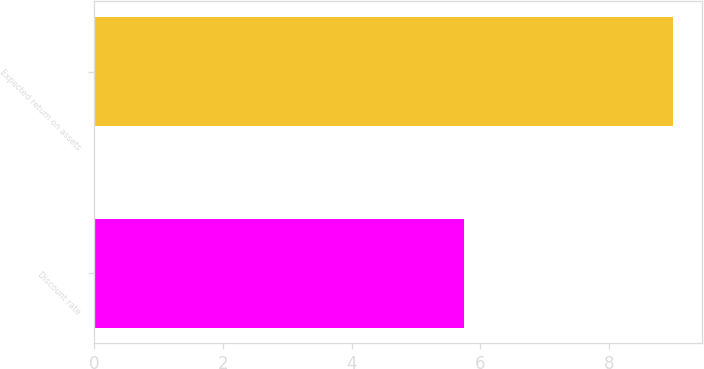Convert chart. <chart><loc_0><loc_0><loc_500><loc_500><bar_chart><fcel>Discount rate<fcel>Expected return on assets<nl><fcel>5.75<fcel>9<nl></chart> 